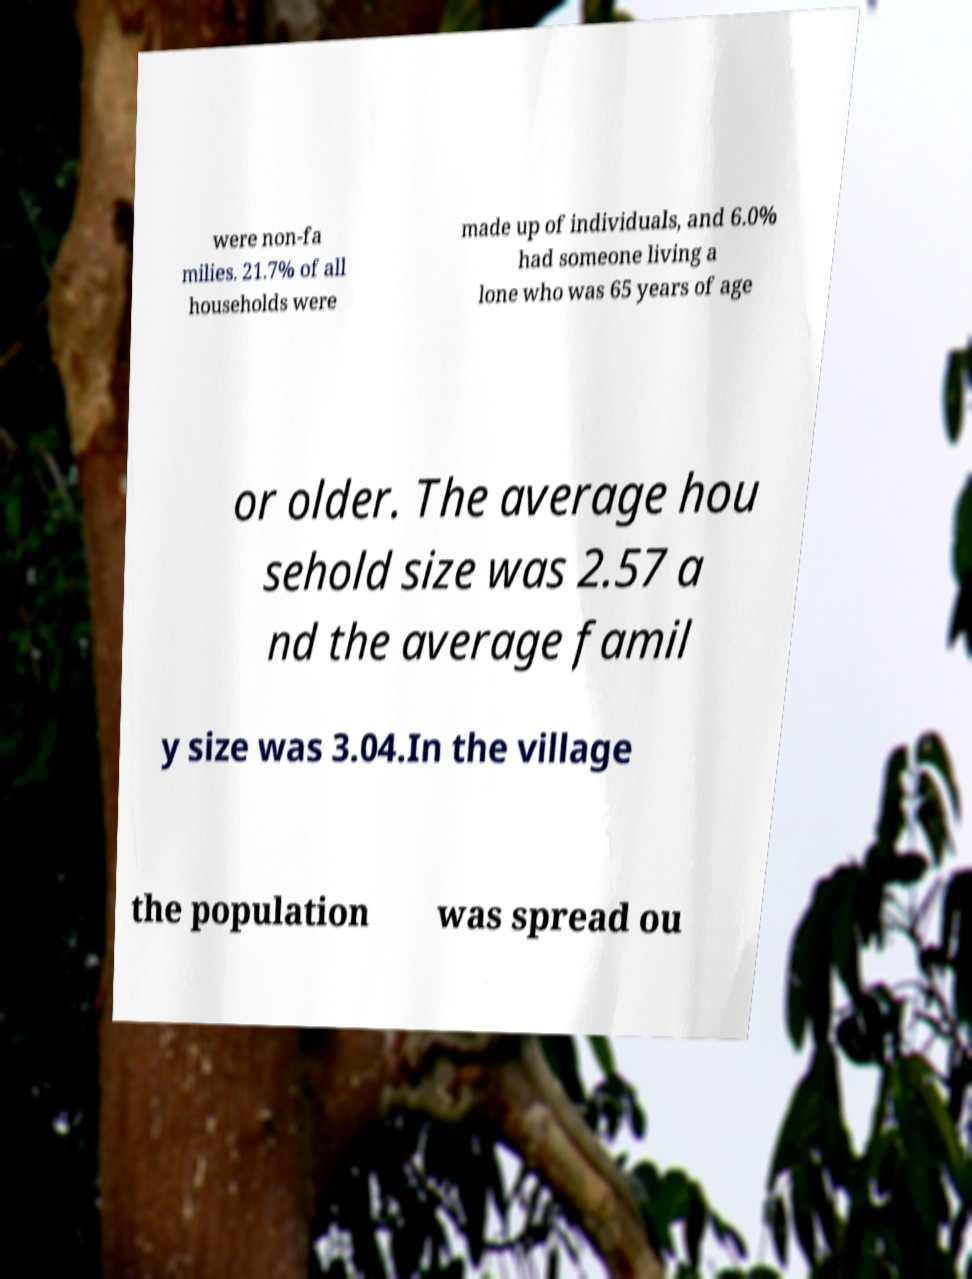Could you assist in decoding the text presented in this image and type it out clearly? were non-fa milies. 21.7% of all households were made up of individuals, and 6.0% had someone living a lone who was 65 years of age or older. The average hou sehold size was 2.57 a nd the average famil y size was 3.04.In the village the population was spread ou 